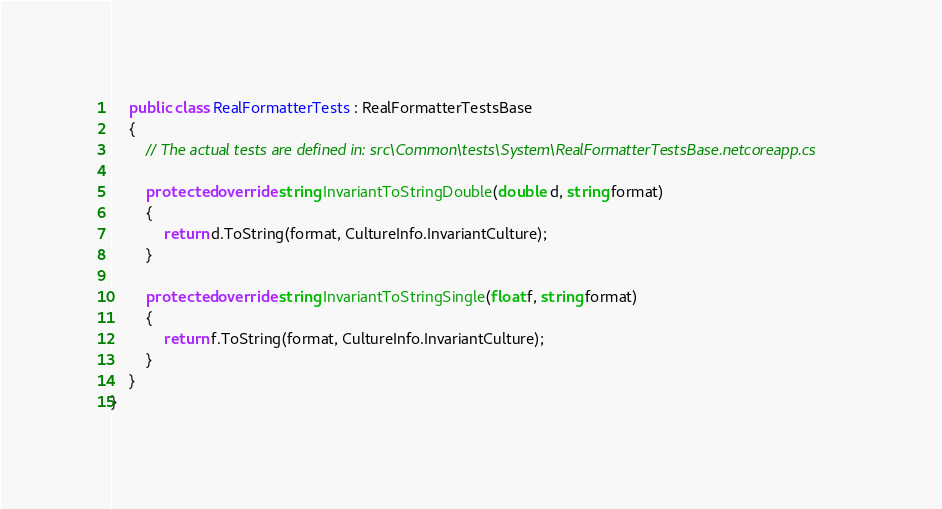<code> <loc_0><loc_0><loc_500><loc_500><_C#_>    public class RealFormatterTests : RealFormatterTestsBase
    {
        // The actual tests are defined in: src\Common\tests\System\RealFormatterTestsBase.netcoreapp.cs

        protected override string InvariantToStringDouble(double d, string format)
        {
            return d.ToString(format, CultureInfo.InvariantCulture);
        }

        protected override string InvariantToStringSingle(float f, string format)
        {
            return f.ToString(format, CultureInfo.InvariantCulture);
        }
    }
}
</code> 